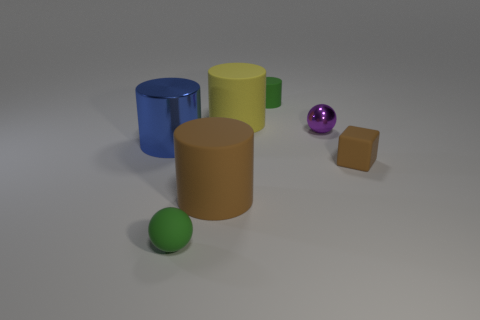There is a rubber block; does it have the same color as the large matte cylinder on the left side of the yellow matte cylinder? Yes, the rubber block shares the same hue of brown as the large matte cylinder situated to the left of the yellow matte cylinder, reflecting consistency in color palette within the given set of objects. 